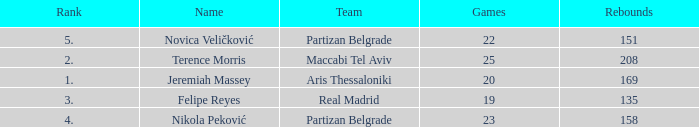How many Games for Terence Morris? 25.0. 